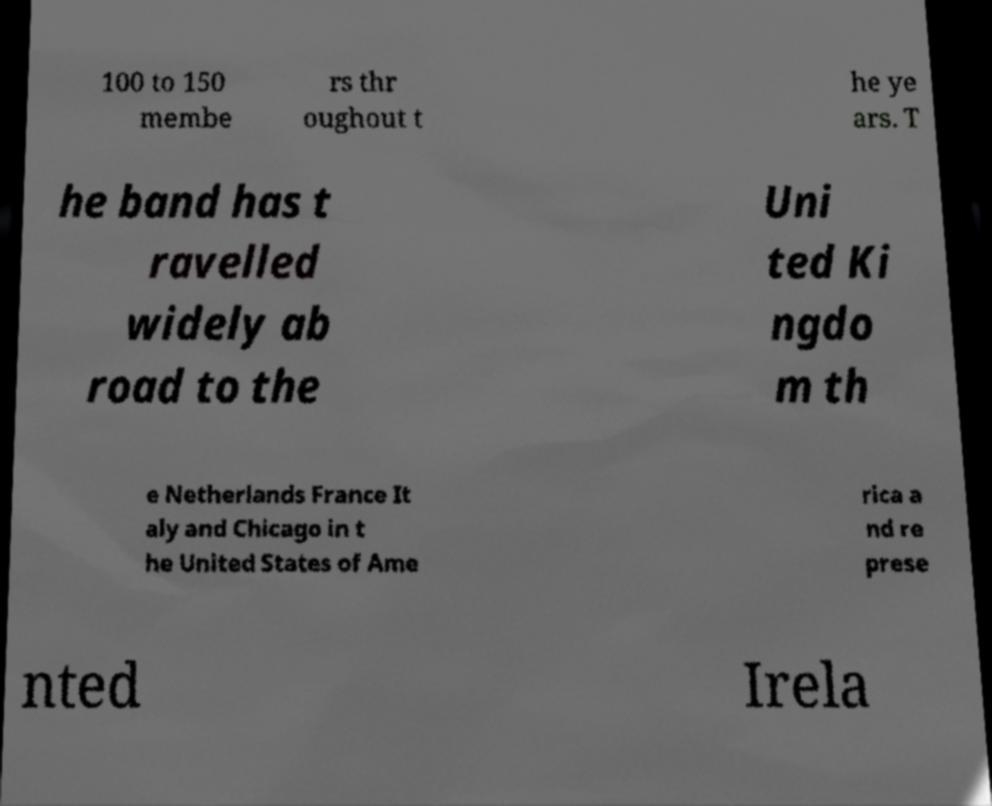I need the written content from this picture converted into text. Can you do that? 100 to 150 membe rs thr oughout t he ye ars. T he band has t ravelled widely ab road to the Uni ted Ki ngdo m th e Netherlands France It aly and Chicago in t he United States of Ame rica a nd re prese nted Irela 